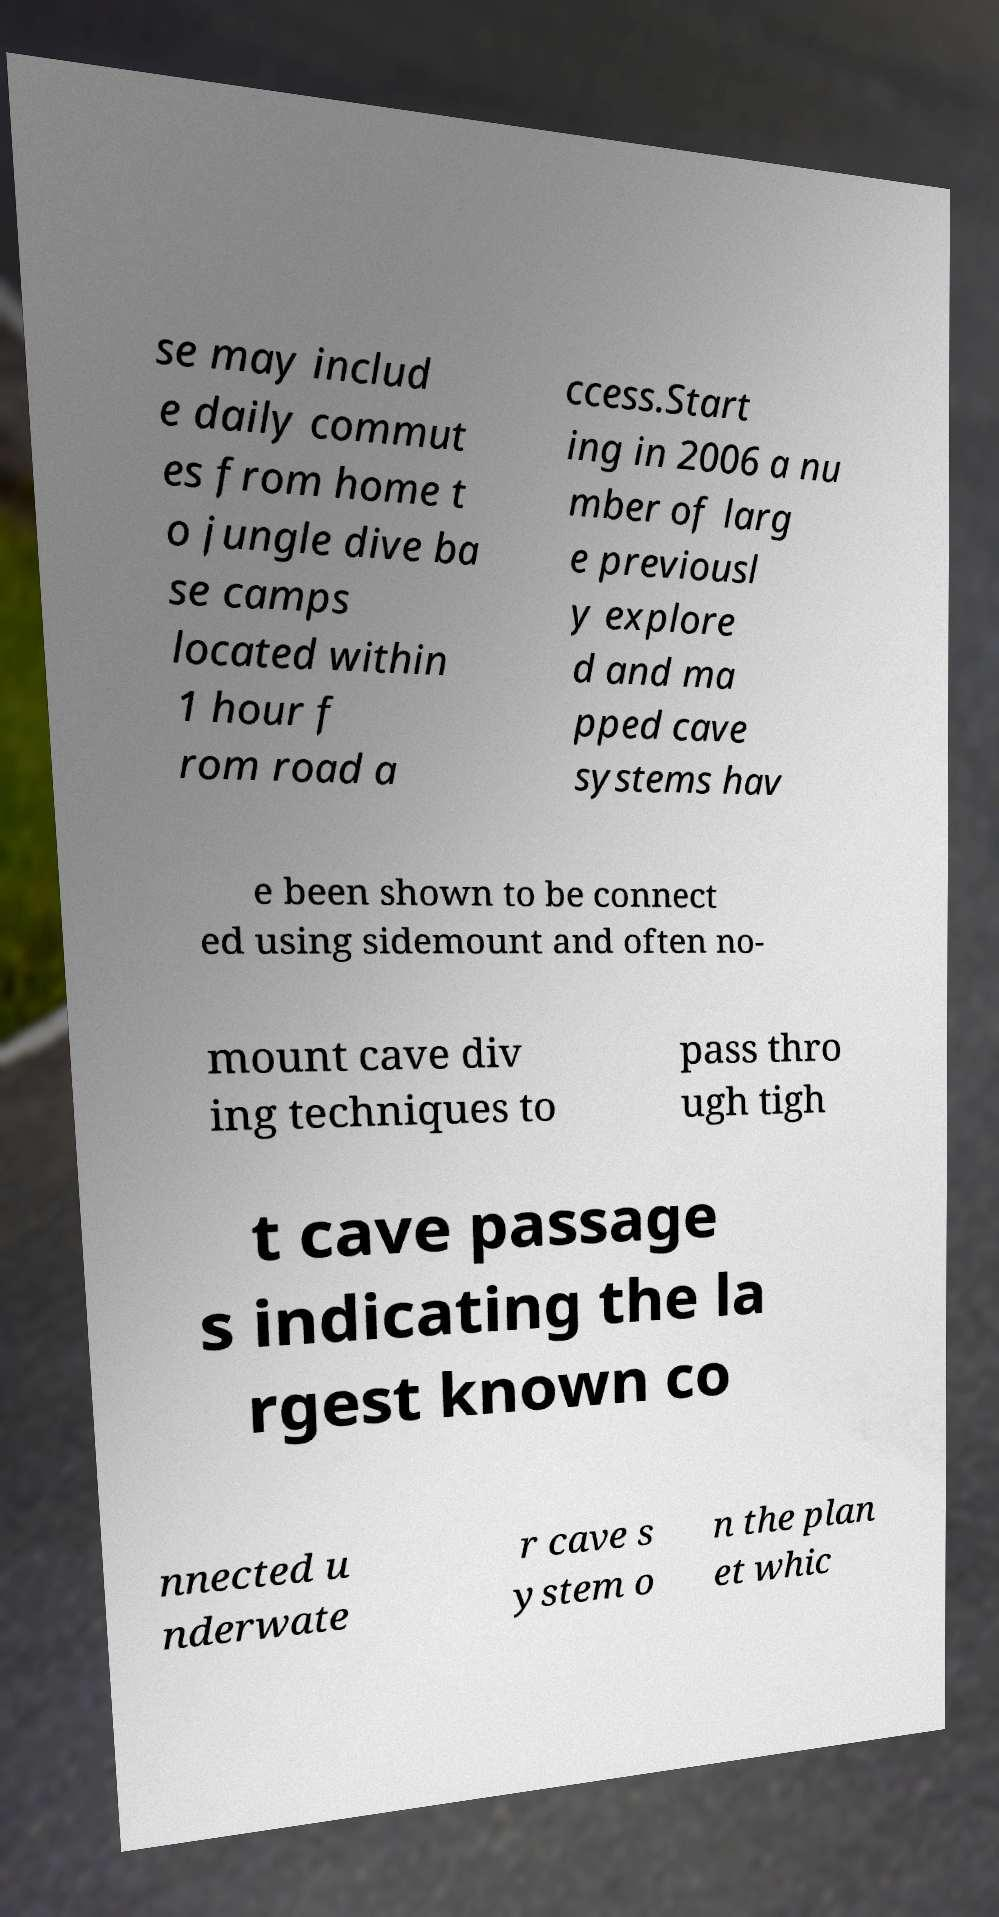For documentation purposes, I need the text within this image transcribed. Could you provide that? se may includ e daily commut es from home t o jungle dive ba se camps located within 1 hour f rom road a ccess.Start ing in 2006 a nu mber of larg e previousl y explore d and ma pped cave systems hav e been shown to be connect ed using sidemount and often no- mount cave div ing techniques to pass thro ugh tigh t cave passage s indicating the la rgest known co nnected u nderwate r cave s ystem o n the plan et whic 